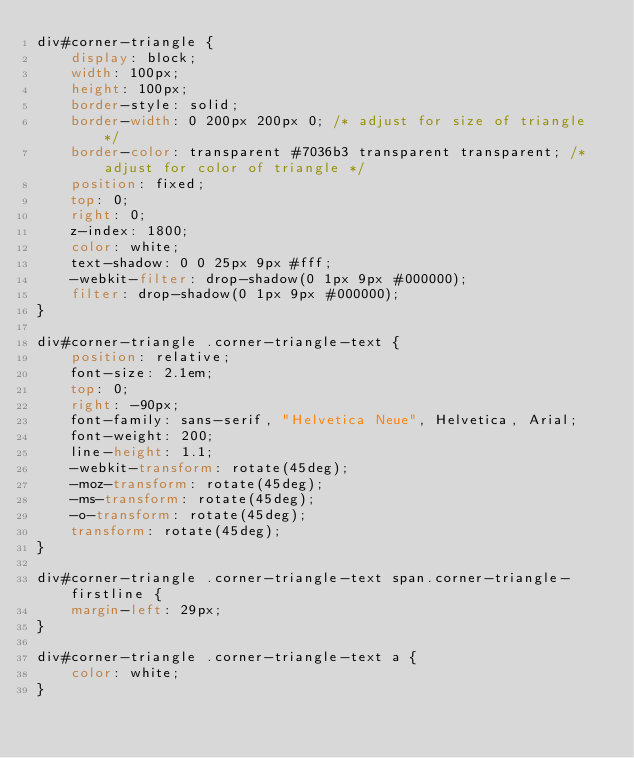<code> <loc_0><loc_0><loc_500><loc_500><_CSS_>div#corner-triangle {
    display: block;
    width: 100px;
    height: 100px;
    border-style: solid;
    border-width: 0 200px 200px 0; /* adjust for size of triangle */
    border-color: transparent #7036b3 transparent transparent; /* adjust for color of triangle */
    position: fixed;
    top: 0;
    right: 0;
    z-index: 1800;
    color: white;
    text-shadow: 0 0 25px 9px #fff;
    -webkit-filter: drop-shadow(0 1px 9px #000000);
    filter: drop-shadow(0 1px 9px #000000);
}

div#corner-triangle .corner-triangle-text {
    position: relative;
    font-size: 2.1em;
    top: 0;
    right: -90px;
    font-family: sans-serif, "Helvetica Neue", Helvetica, Arial;
    font-weight: 200;
    line-height: 1.1;
    -webkit-transform: rotate(45deg);
    -moz-transform: rotate(45deg);
    -ms-transform: rotate(45deg);
    -o-transform: rotate(45deg);
    transform: rotate(45deg);
}

div#corner-triangle .corner-triangle-text span.corner-triangle-firstline {
    margin-left: 29px;
}

div#corner-triangle .corner-triangle-text a {
    color: white;
}

</code> 